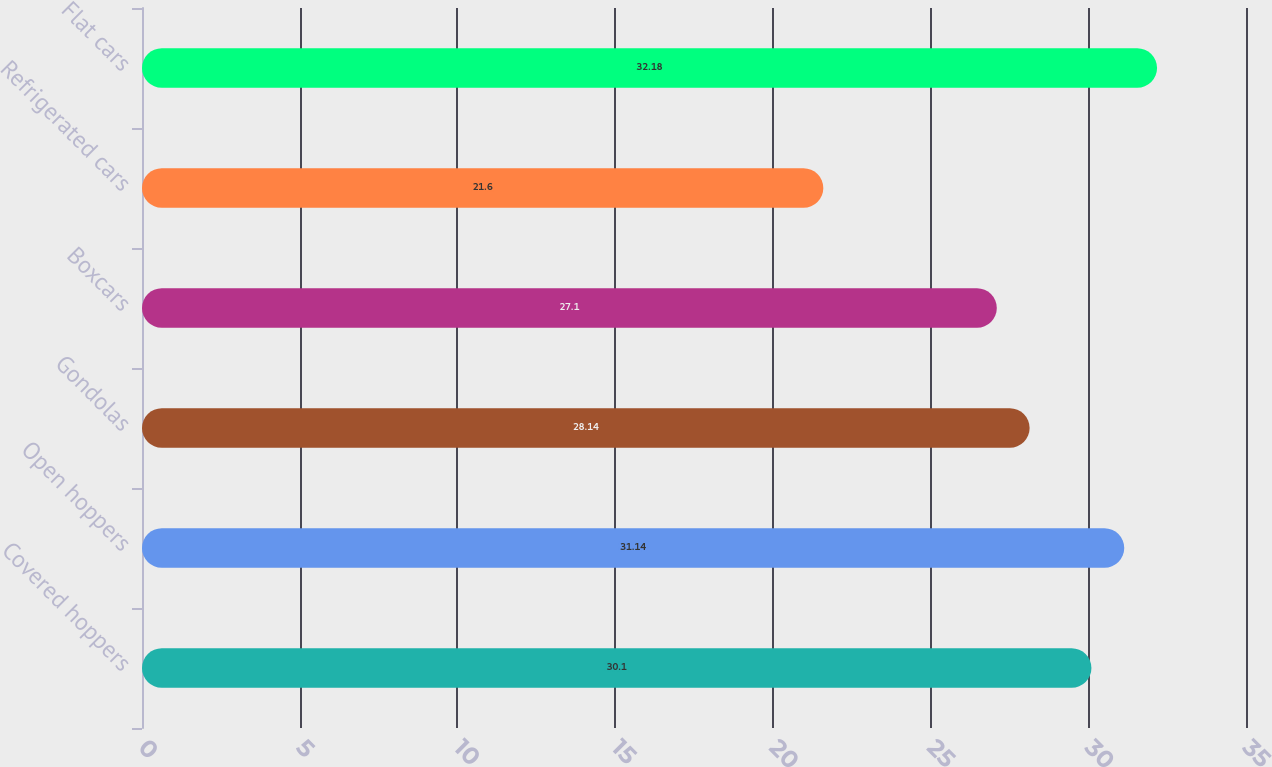<chart> <loc_0><loc_0><loc_500><loc_500><bar_chart><fcel>Covered hoppers<fcel>Open hoppers<fcel>Gondolas<fcel>Boxcars<fcel>Refrigerated cars<fcel>Flat cars<nl><fcel>30.1<fcel>31.14<fcel>28.14<fcel>27.1<fcel>21.6<fcel>32.18<nl></chart> 